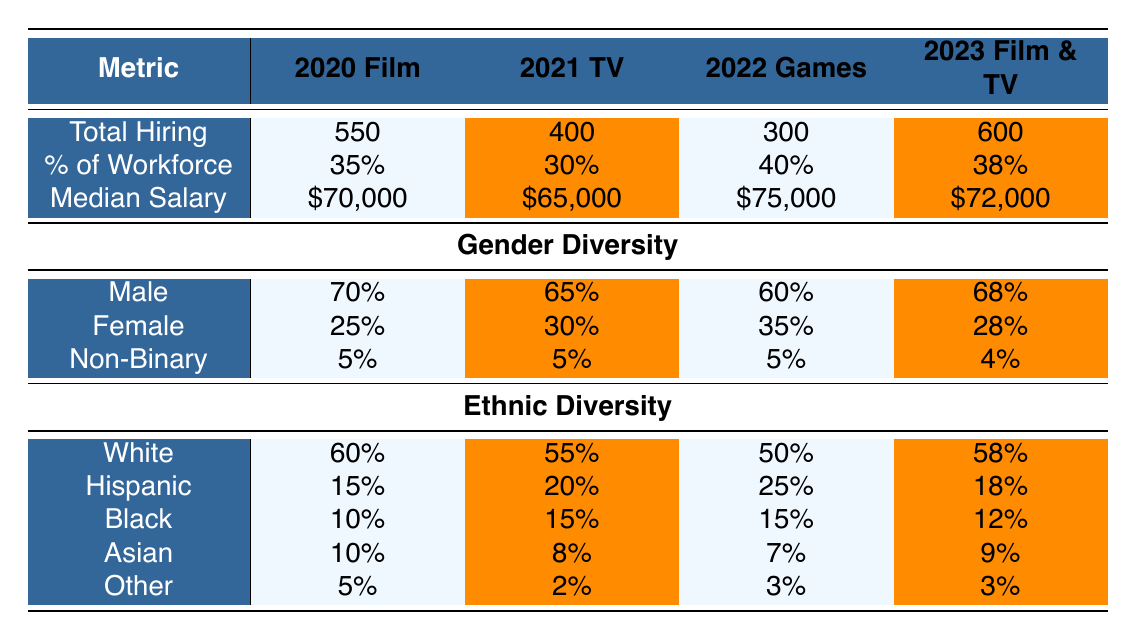What was the total hiring of special effects artists in the film industry in 2020? The data for total hiring in the film industry in 2020 is directly provided in the table, which states it as 550.
Answer: 550 What was the median salary for special effects artists in the video game industry in 2022? The median salary specific to the video game industry in 2022 is listed as 75,000 in the table.
Answer: 75,000 Is there a higher percentage of ethnic diversity in 2021 compared to 2020 for Black special effects artists? The percentage for Black special effects artists in 2021 is 15%, while in 2020 it was 10%. Since 15% is higher than 10%, the statement is true.
Answer: Yes What was the average total hiring of special effects artists across the years 2020 to 2023? The total hiring across these years is: 550 (2020) + 400 (2021) + 300 (2022) + 600 (2023) = 1850. Dividing by 4 gives 1850/4 = 462.5.
Answer: 462.5 Does the percentage of male special effects artists in 2023 exceed 65%? The table shows that the percentage of male special effects artists in 2023 is 68%, which exceeds 65%. Therefore, the answer is true.
Answer: Yes What is the difference in median salary between special effects artists in the video game industry and those in film & television in 2023? The median salary for video game artists in 2022 is 75,000, while for film & television artists in 2023 it is 72,000. The difference is 75,000 - 72,000 = 3,000.
Answer: 3,000 What percentage of the total workforce made up female special effects artists in 2021? The percentage of female special effects artists specifically stated for 2021 is 30%, as indicated in the table.
Answer: 30 Which year saw the highest percentage of female special effects artists? By comparing the percentages of females across the years, 2022 has the highest percentage at 35%.
Answer: 2022 How has the percentage of Hispanic special effects artists changed from 2021 to 2023? In 2021, the percentage of Hispanic artists was 20%, and in 2023 it decreased to 18%. This indicates a decrease of 2 percentage points.
Answer: Decreased by 2 percentage points 